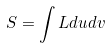<formula> <loc_0><loc_0><loc_500><loc_500>S = \int L d u d v</formula> 